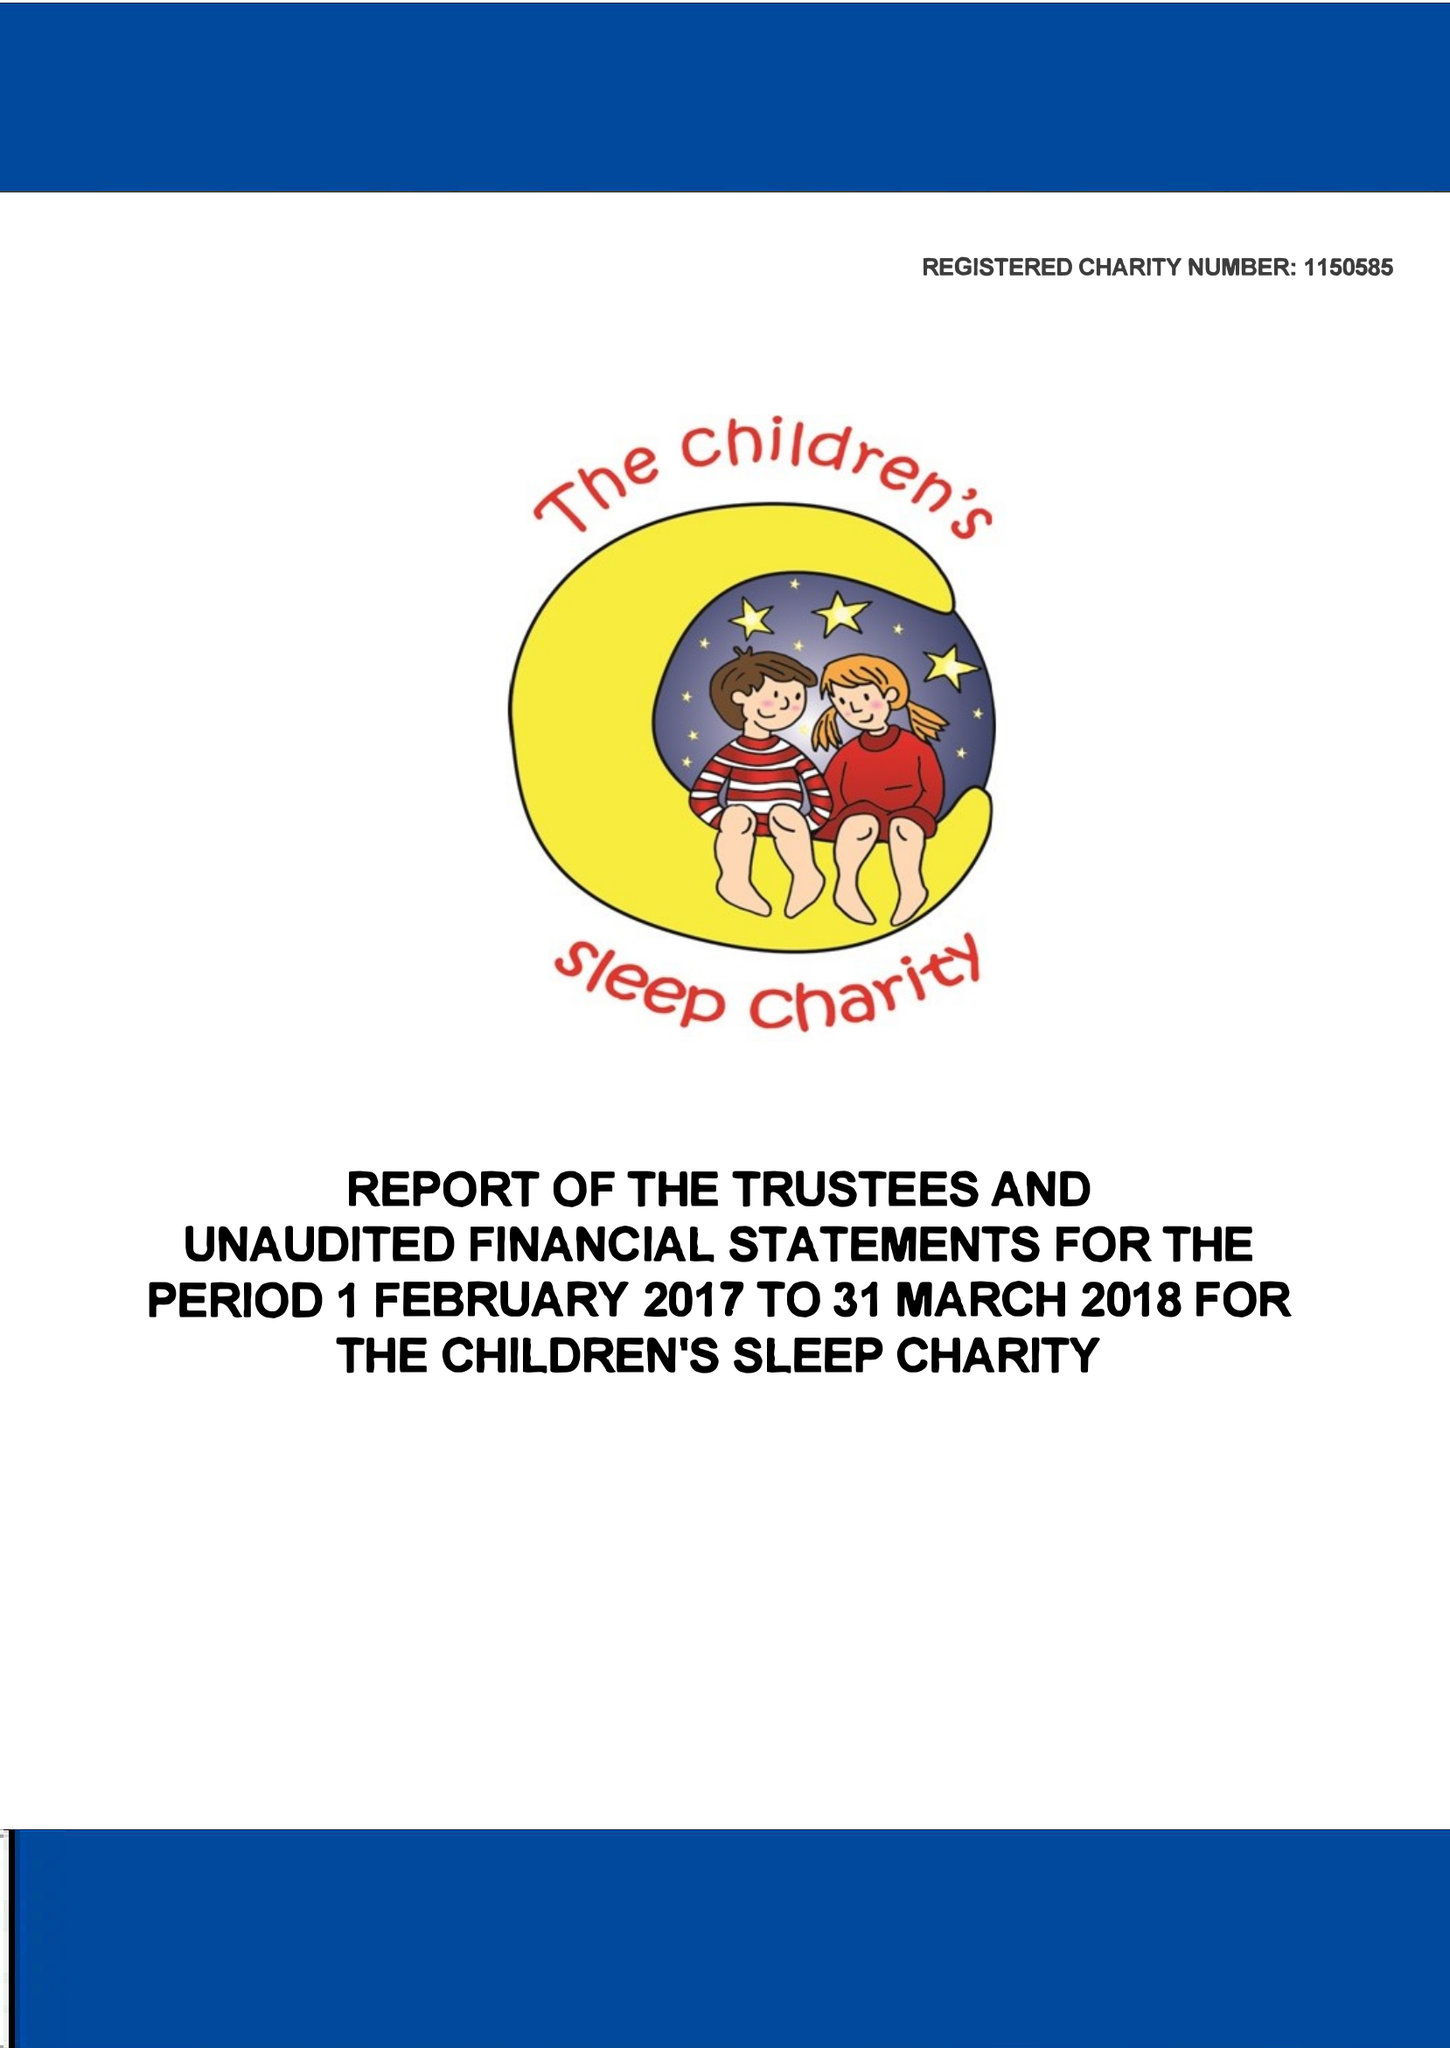What is the value for the charity_name?
Answer the question using a single word or phrase. The Children's Sleep Charity 